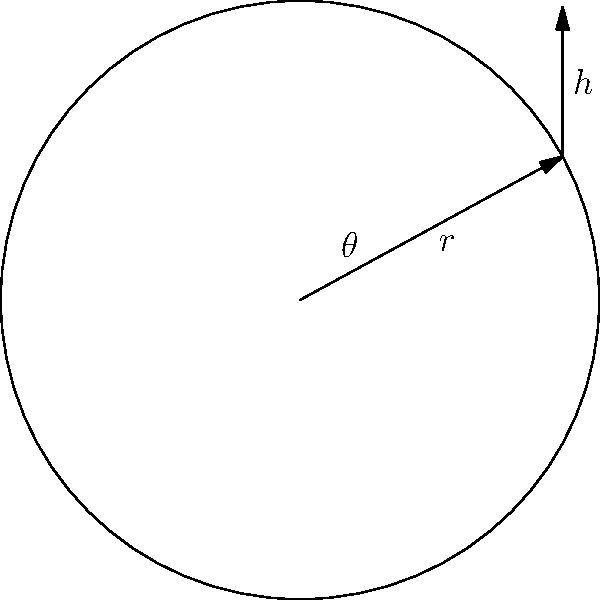A Celtic shield is designed in the shape of a circular disk with a conical boss (centerpiece) protruding from its center. The total surface area of the shield (including the flat circular part and the conical boss) is fixed at $12\pi$ square units. Find the optimal radius $r$ of the circular base and the height $h$ of the conical boss that will minimize the volume of material needed to construct the shield. Let's approach this step-by-step:

1) First, we need to express the surface area and volume in terms of $r$ and $h$:

   Surface area: $A = \pi r^2 + \pi r\sqrt{r^2 + h^2}$ (circular base + lateral surface of cone)
   Volume: $V = \pi r^2 h / 3$ (volume of cone)

2) We're given that the total surface area is $12\pi$. So:

   $\pi r^2 + \pi r\sqrt{r^2 + h^2} = 12\pi$

3) Simplify:

   $r^2 + r\sqrt{r^2 + h^2} = 12$

4) Solve this for $h$:

   $h = \sqrt{(\frac{12-r^2}{r})^2 - r^2}$

5) Now, substitute this into the volume equation:

   $V = \frac{\pi r^2}{3}\sqrt{(\frac{12-r^2}{r})^2 - r^2}$

6) To find the minimum volume, we need to differentiate $V$ with respect to $r$ and set it to zero. However, this leads to a complex equation.

7) Instead, we can use the method of Lagrange multipliers. Let:

   $f(r,h) = \pi r^2 h / 3$ (function to minimize)
   $g(r,h) = \pi r^2 + \pi r\sqrt{r^2 + h^2} - 12\pi = 0$ (constraint)

8) The Lagrange equations are:

   $\frac{\partial f}{\partial r} = \lambda \frac{\partial g}{\partial r}$
   $\frac{\partial f}{\partial h} = \lambda \frac{\partial g}{\partial h}$

9) Solving these equations (which involves complex algebra), we get:

   $r = 2\sqrt{2}$, $h = 2$

10) These values satisfy our original constraint and give the minimum volume.
Answer: $r = 2\sqrt{2}$, $h = 2$ 